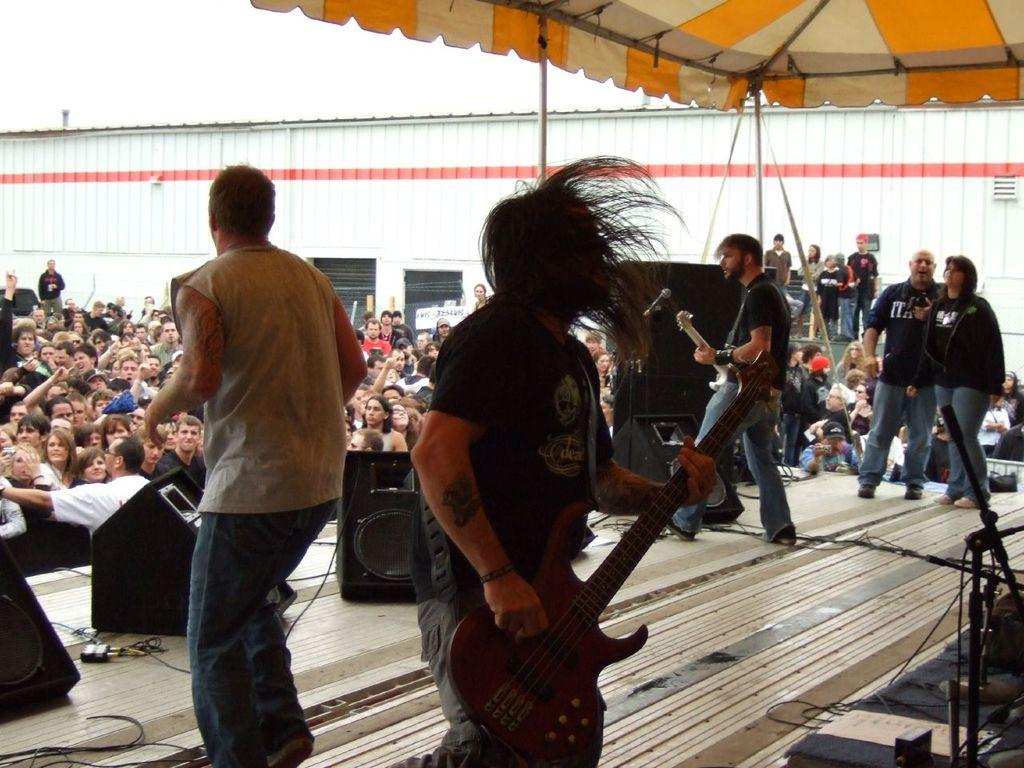What activity are the people in the image engaged in? The people in the image are performing a stage show. What are the performers using during the show? The performers are using different musical instruments. Are there any spectators present in the image? Yes, there are people watching the stage show. What can be seen in the background of the image? The sky is visible and clear in the image. What is the tendency of the record in the image? There is no record present in the image, so it is not possible to determine any tendencies. 